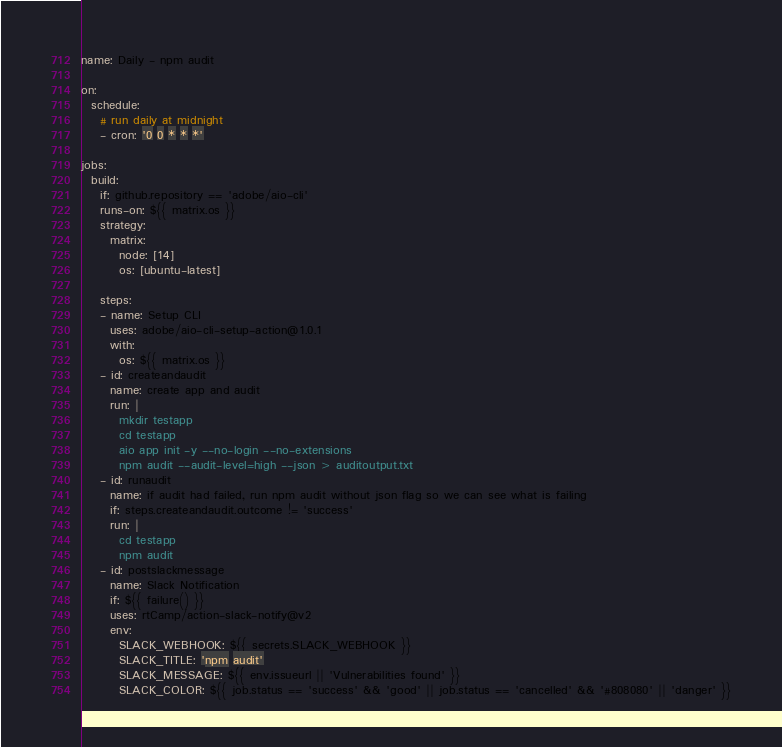<code> <loc_0><loc_0><loc_500><loc_500><_YAML_>name: Daily - npm audit

on:
  schedule:
    # run daily at midnight
    - cron: '0 0 * * *'

jobs:
  build:
    if: github.repository == 'adobe/aio-cli'
    runs-on: ${{ matrix.os }}
    strategy:
      matrix:
        node: [14]
        os: [ubuntu-latest]

    steps:
    - name: Setup CLI
      uses: adobe/aio-cli-setup-action@1.0.1
      with:
        os: ${{ matrix.os }}
    - id: createandaudit
      name: create app and audit
      run: |
        mkdir testapp
        cd testapp
        aio app init -y --no-login --no-extensions
        npm audit --audit-level=high --json > auditoutput.txt
    - id: runaudit
      name: if audit had failed, run npm audit without json flag so we can see what is failing
      if: steps.createandaudit.outcome != 'success'
      run: |
        cd testapp
        npm audit
    - id: postslackmessage
      name: Slack Notification
      if: ${{ failure() }}
      uses: rtCamp/action-slack-notify@v2
      env:
        SLACK_WEBHOOK: ${{ secrets.SLACK_WEBHOOK }}
        SLACK_TITLE: 'npm audit'
        SLACK_MESSAGE: ${{ env.issueurl || 'Vulnerabilities found' }}
        SLACK_COLOR: ${{ job.status == 'success' && 'good' || job.status == 'cancelled' && '#808080' || 'danger' }}
</code> 